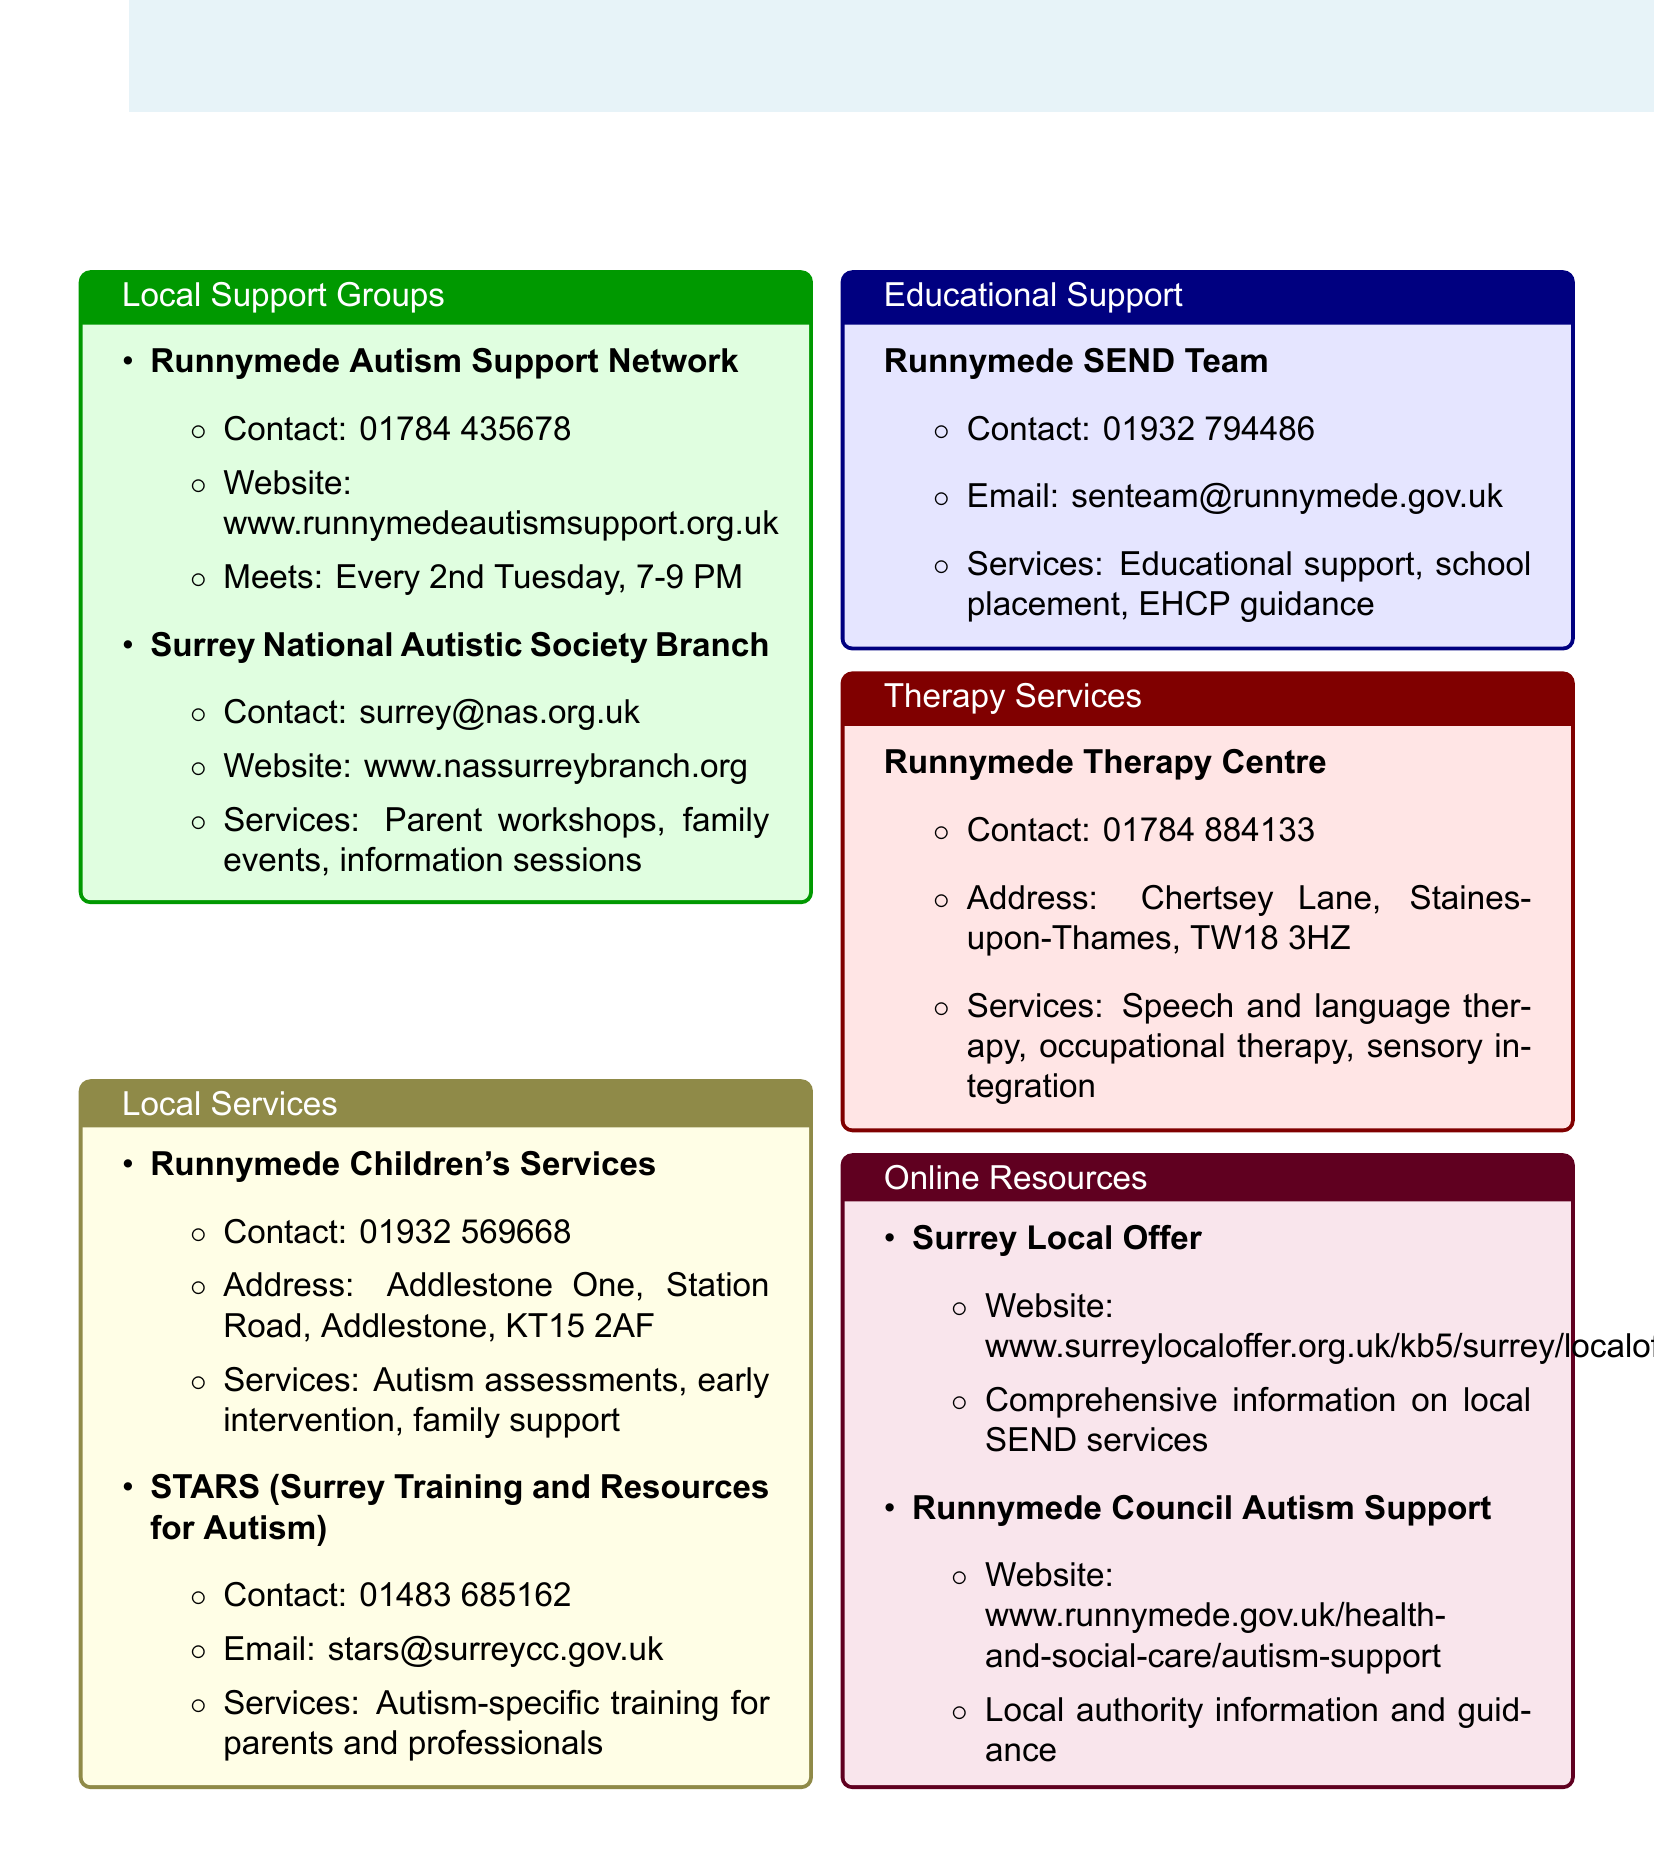What is the contact number for Runnymede Autism Support Network? The contact number is provided under the Runnymede Autism Support Network section.
Answer: 01784 435678 What services does STARS offer? The services offered by STARS are listed in the Local Services section.
Answer: Autism-specific training for parents and professionals When does the Runnymede Autism Support Network meet? The meeting schedule is included in the description of the Runnymede Autism Support Network.
Answer: Every 2nd Tuesday, 7-9 PM What is the address of Runnymede Children's Services? The address is specified in the Local Services section under Runnymede Children's Services.
Answer: Addlestone One, Station Road, Addlestone, KT15 2AF What educational support does the Runnymede SEND Team provide? The services provided by the Runnymede SEND Team are mentioned in the Educational Support section.
Answer: Educational support, school placement, EHCP guidance Which local resource offers comprehensive information on SEND services? This information is stated in the Online Resources section and refers to a specific local offer.
Answer: Surrey Local Offer What is the contact email for the Runnymede SEND Team? The contact email is provided in the Educational Support section.
Answer: senteam@runnymede.gov.uk What type of therapy services does Runnymede Therapy Centre provide? The types of therapy services are listed under Runnymede Therapy Centre in the Therapy Services section.
Answer: Speech and language therapy, occupational therapy, sensory integration 